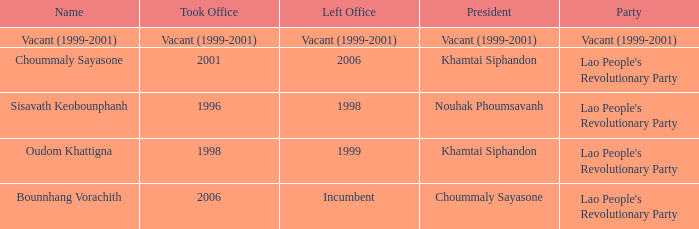What is Left Office, when Took Office is 1998? 1999.0. 